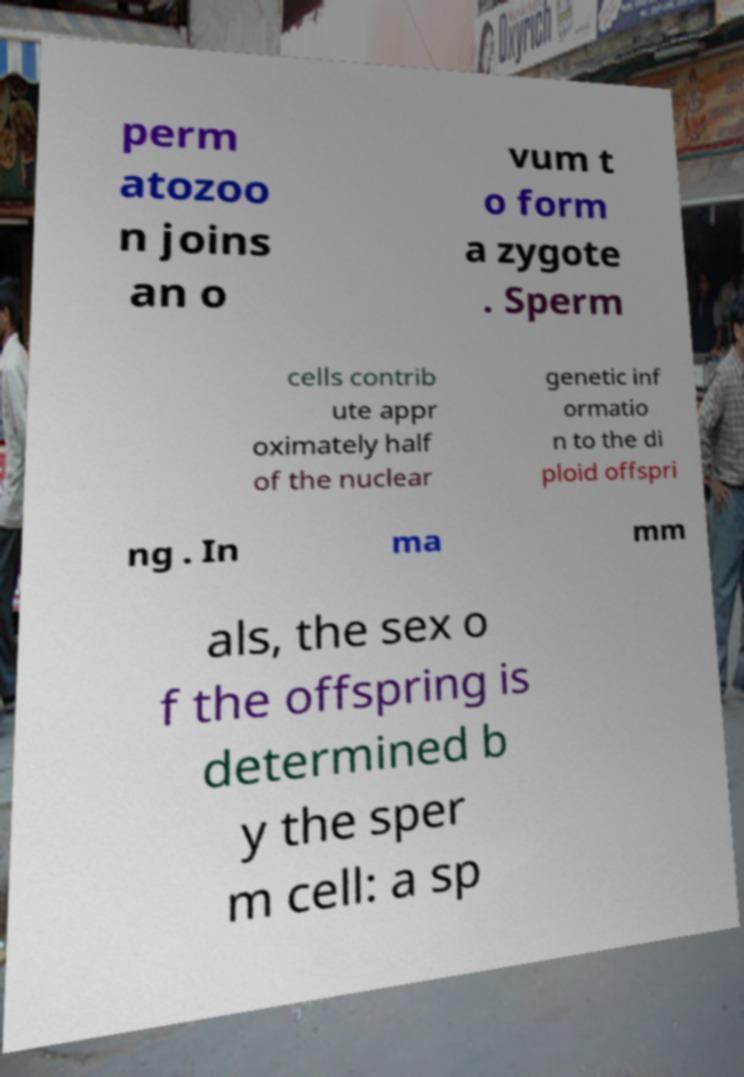What messages or text are displayed in this image? I need them in a readable, typed format. perm atozoo n joins an o vum t o form a zygote . Sperm cells contrib ute appr oximately half of the nuclear genetic inf ormatio n to the di ploid offspri ng . In ma mm als, the sex o f the offspring is determined b y the sper m cell: a sp 